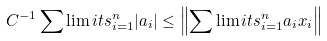Convert formula to latex. <formula><loc_0><loc_0><loc_500><loc_500>C ^ { - 1 } \sum \lim i t s _ { i = 1 } ^ { n } | a _ { i } | \leq \left \| \sum \lim i t s _ { i = 1 } ^ { n } a _ { i } x _ { i } \right \|</formula> 